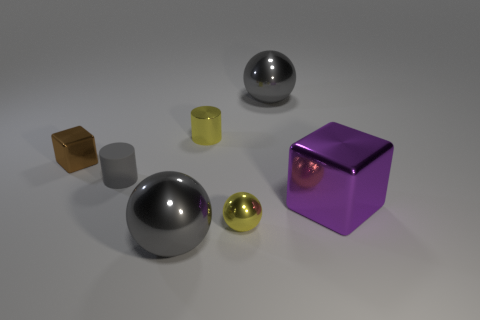Can you comment on the lighting in this scene? The lighting in this scene is soft and seems to be overhead, casting gentle shadows that softly outline each object without creating overly harsh contrasts. 